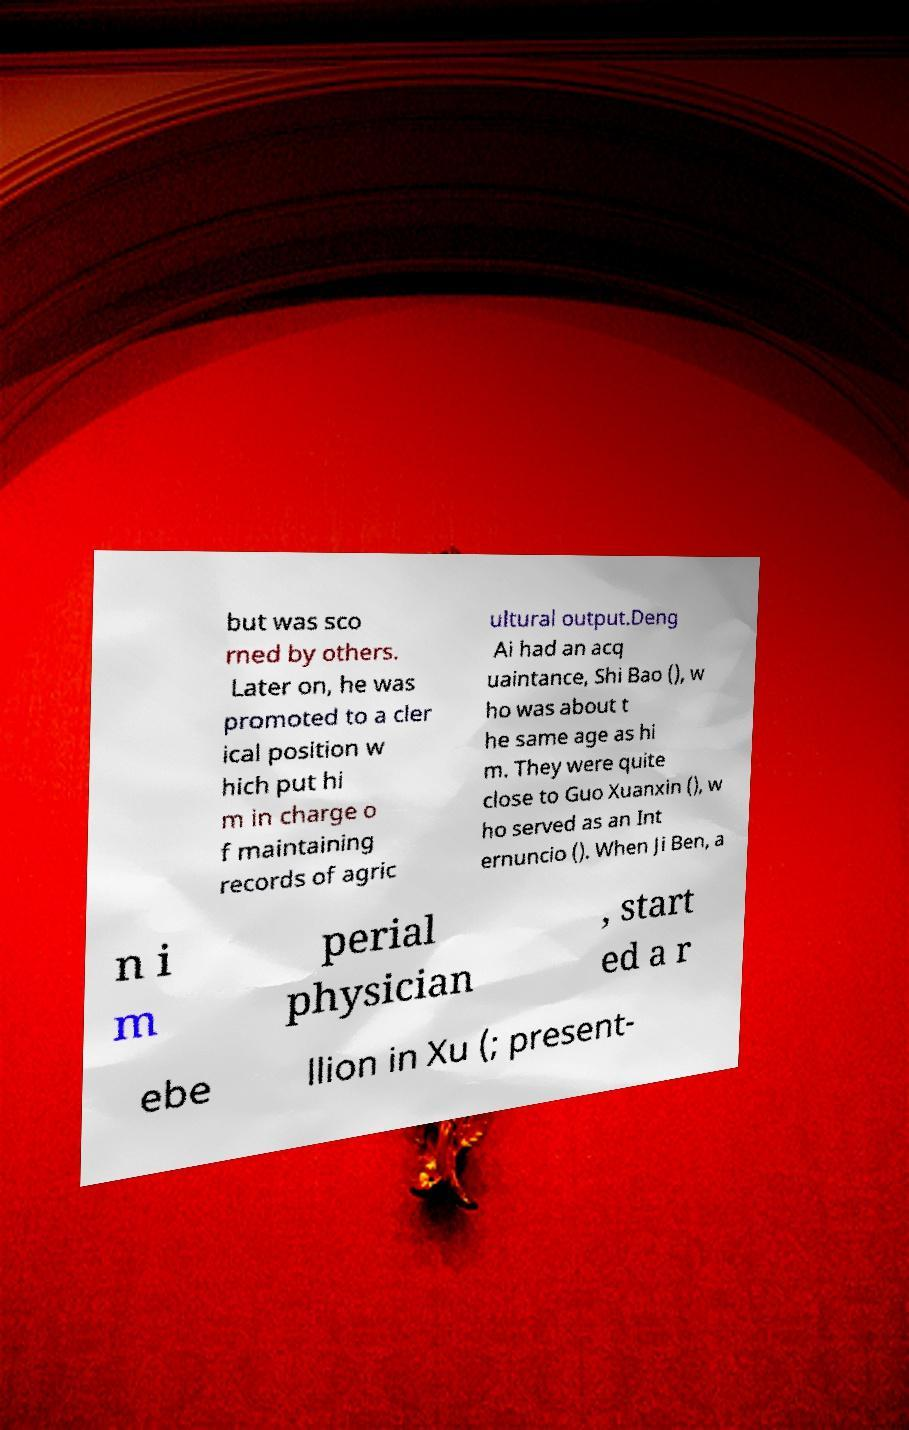Can you accurately transcribe the text from the provided image for me? but was sco rned by others. Later on, he was promoted to a cler ical position w hich put hi m in charge o f maintaining records of agric ultural output.Deng Ai had an acq uaintance, Shi Bao (), w ho was about t he same age as hi m. They were quite close to Guo Xuanxin (), w ho served as an Int ernuncio (). When Ji Ben, a n i m perial physician , start ed a r ebe llion in Xu (; present- 